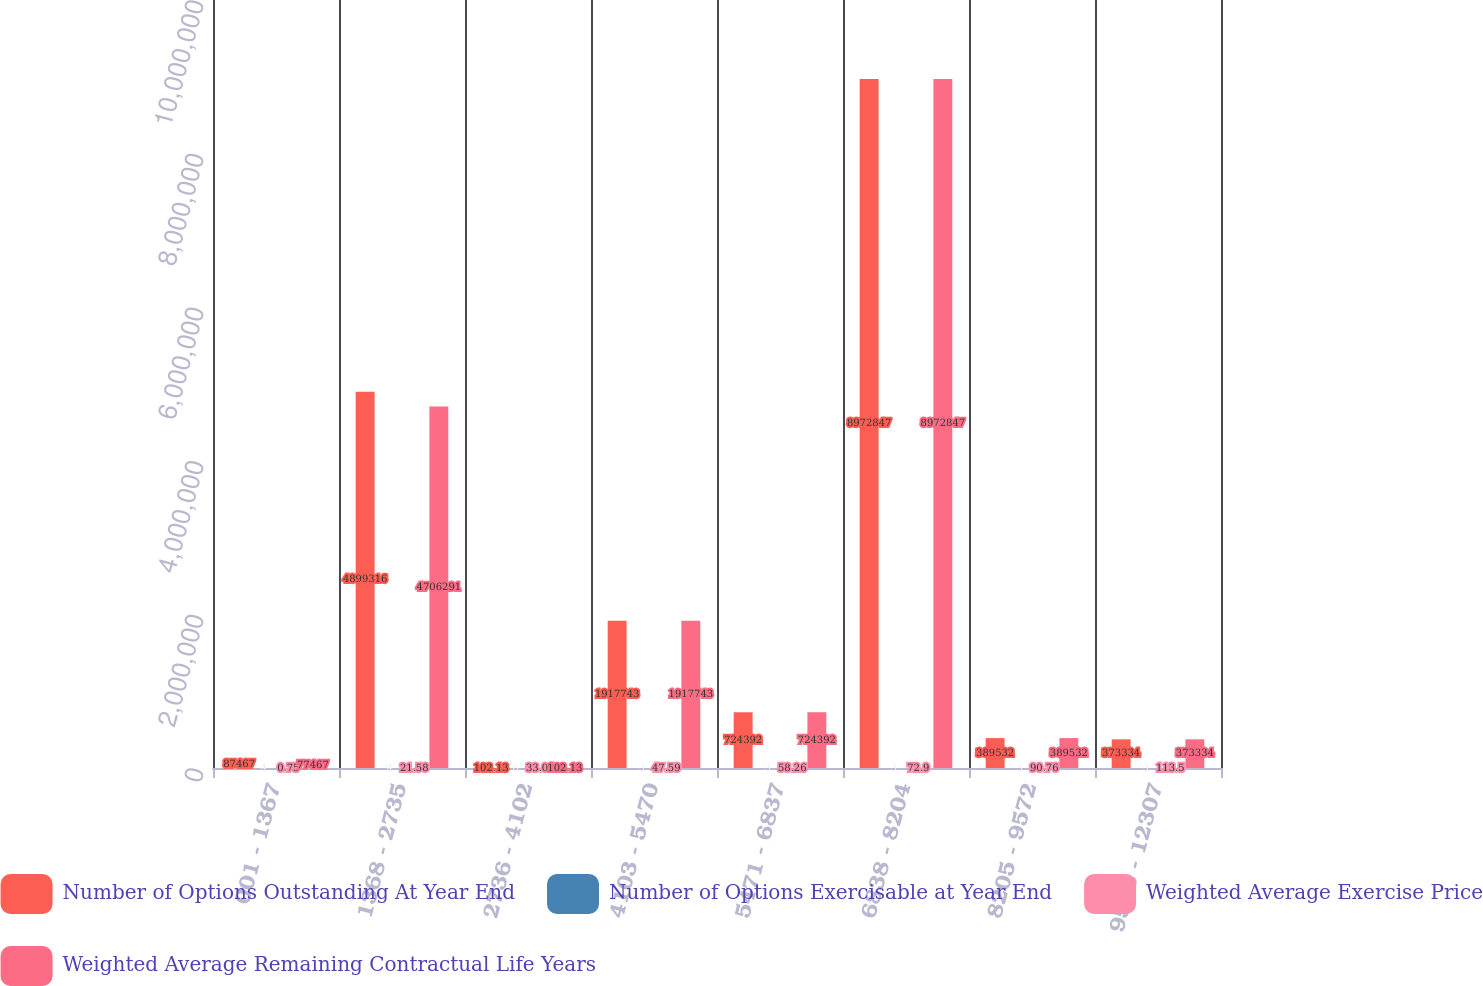<chart> <loc_0><loc_0><loc_500><loc_500><stacked_bar_chart><ecel><fcel>001 - 1367<fcel>1368 - 2735<fcel>2736 - 4102<fcel>4103 - 5470<fcel>5471 - 6837<fcel>6838 - 8204<fcel>8205 - 9572<fcel>9573 - 12307<nl><fcel>Number of Options Outstanding At Year End<fcel>87467<fcel>4.89932e+06<fcel>102.13<fcel>1.91774e+06<fcel>724392<fcel>8.97285e+06<fcel>389532<fcel>373334<nl><fcel>Number of Options Exercisable at Year End<fcel>4<fcel>4<fcel>6<fcel>3<fcel>3<fcel>3<fcel>3<fcel>3<nl><fcel>Weighted Average Exercise Price<fcel>0.75<fcel>21.58<fcel>33.04<fcel>47.59<fcel>58.26<fcel>72.9<fcel>90.76<fcel>113.5<nl><fcel>Weighted Average Remaining Contractual Life Years<fcel>77467<fcel>4.70629e+06<fcel>102.13<fcel>1.91774e+06<fcel>724392<fcel>8.97285e+06<fcel>389532<fcel>373334<nl></chart> 